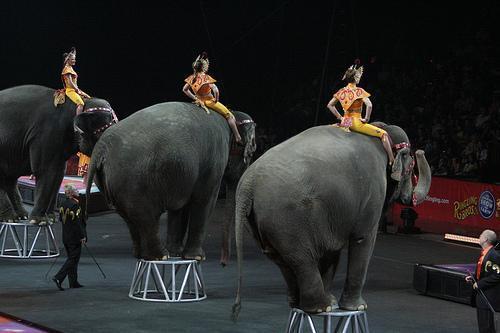How many elephants are in picture?
Give a very brief answer. 3. 